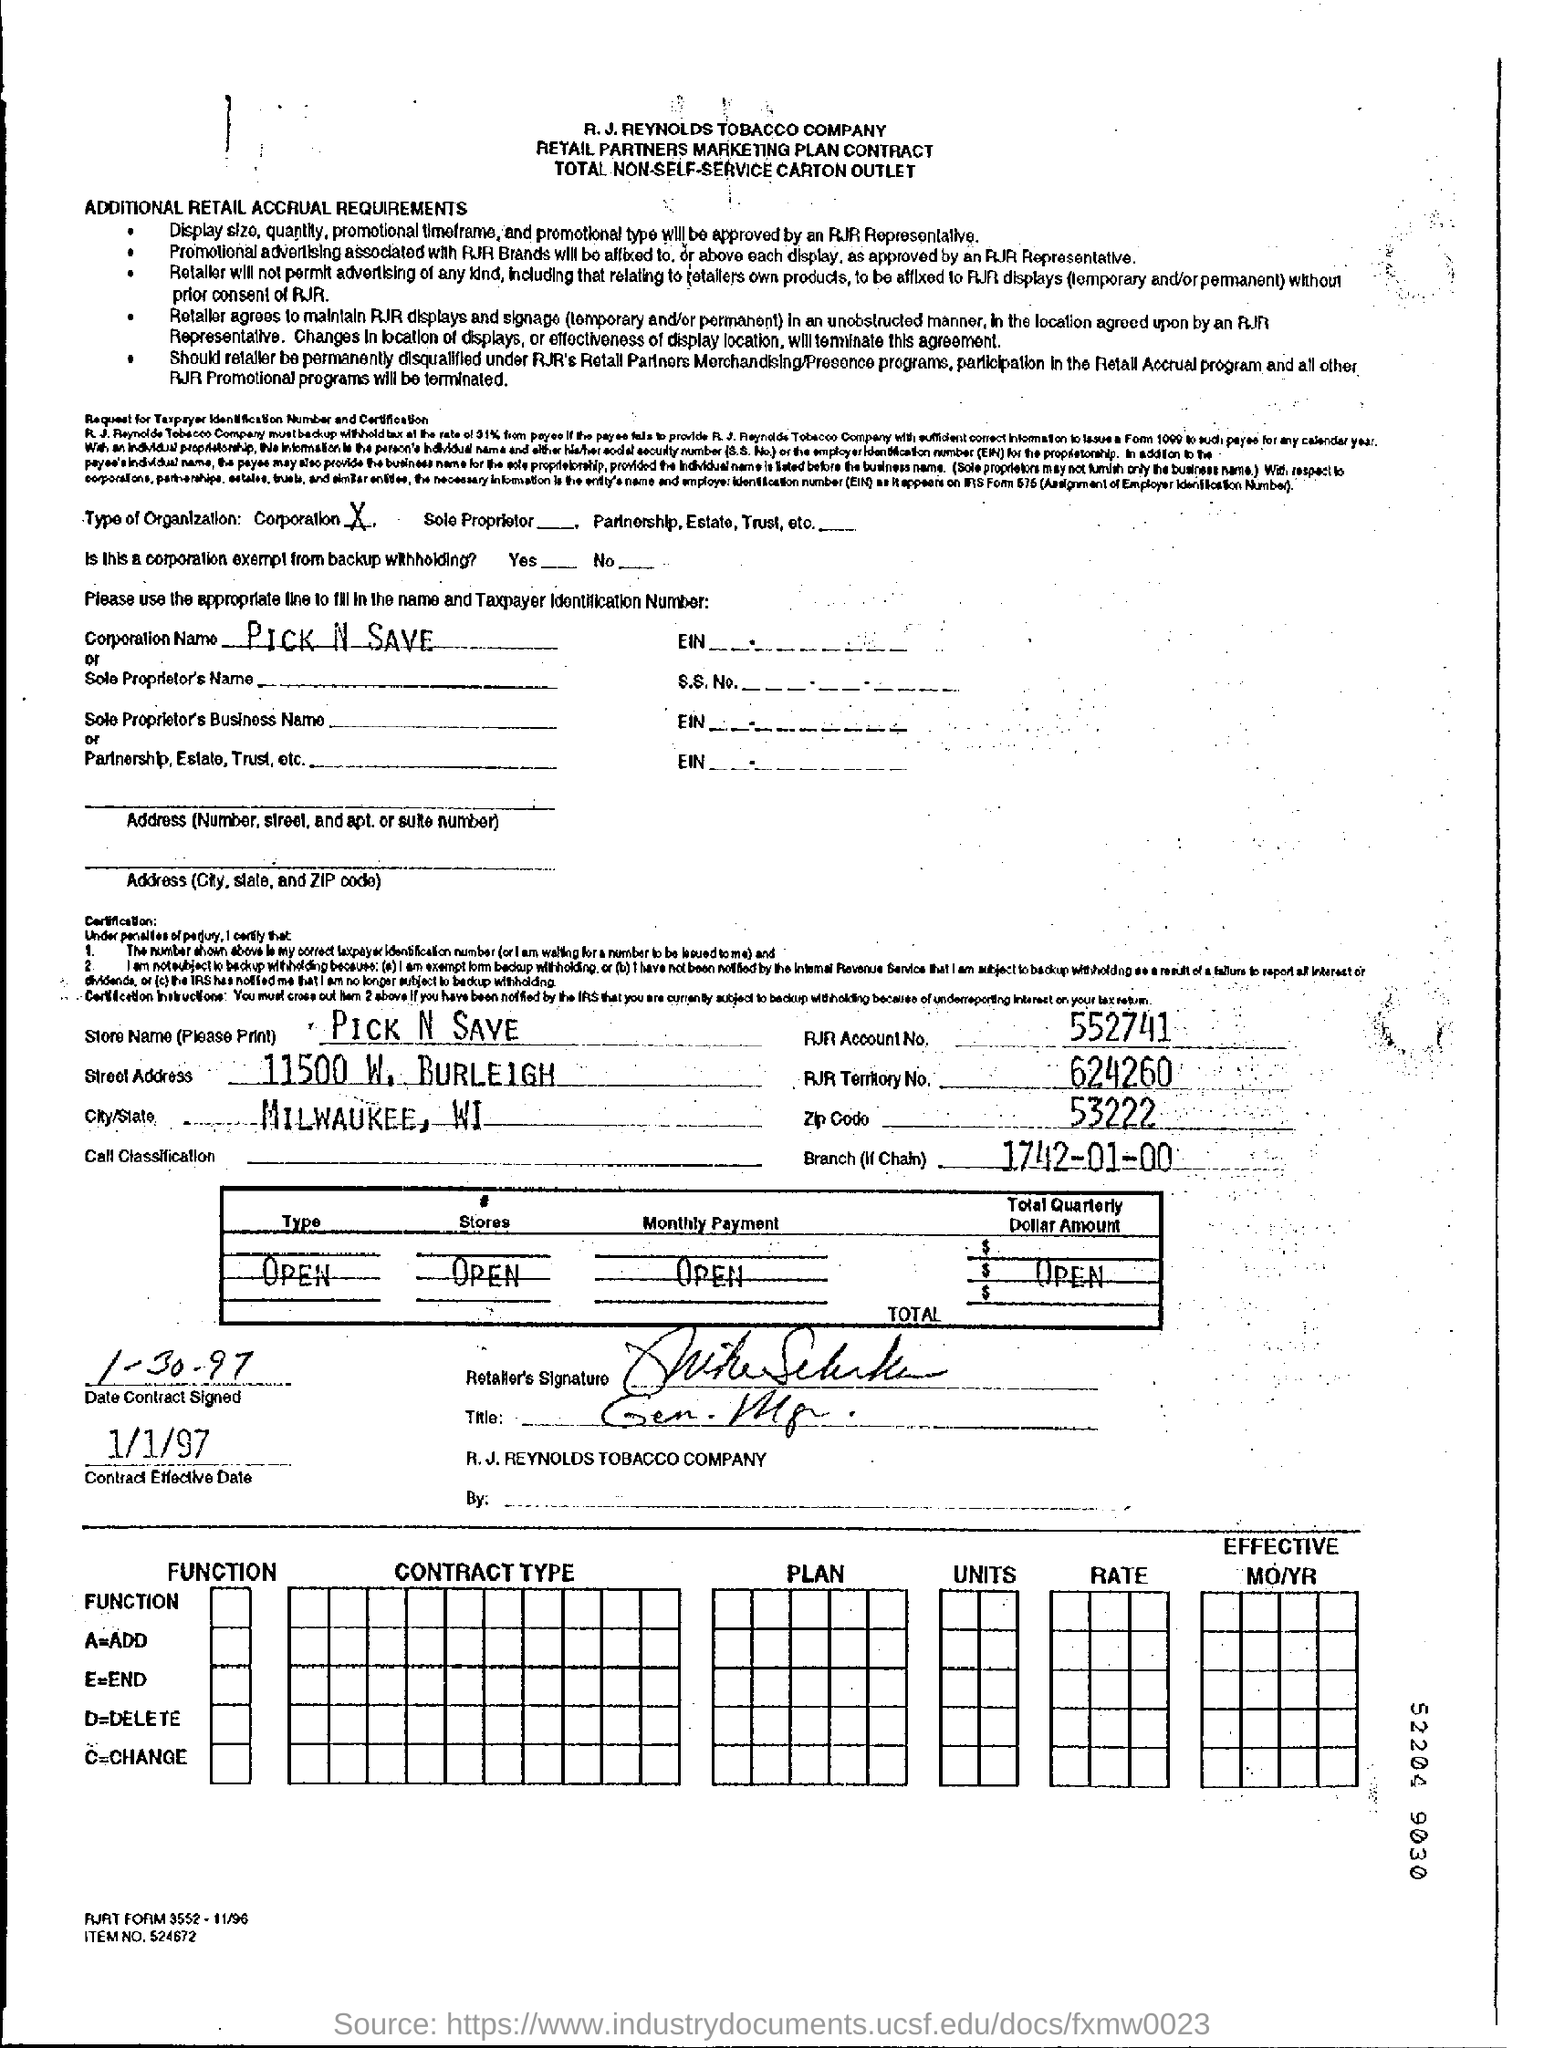What is the Store Name mentioned in the form?
Your response must be concise. PICK N SAVE. What is the name of the corporation?
Make the answer very short. Pick n save. What is the RJR account no given in the form?
Give a very brief answer. 552741. What is rjr account number?
Provide a succinct answer. 552741. What is the zip code?
Provide a short and direct response. 53222. 